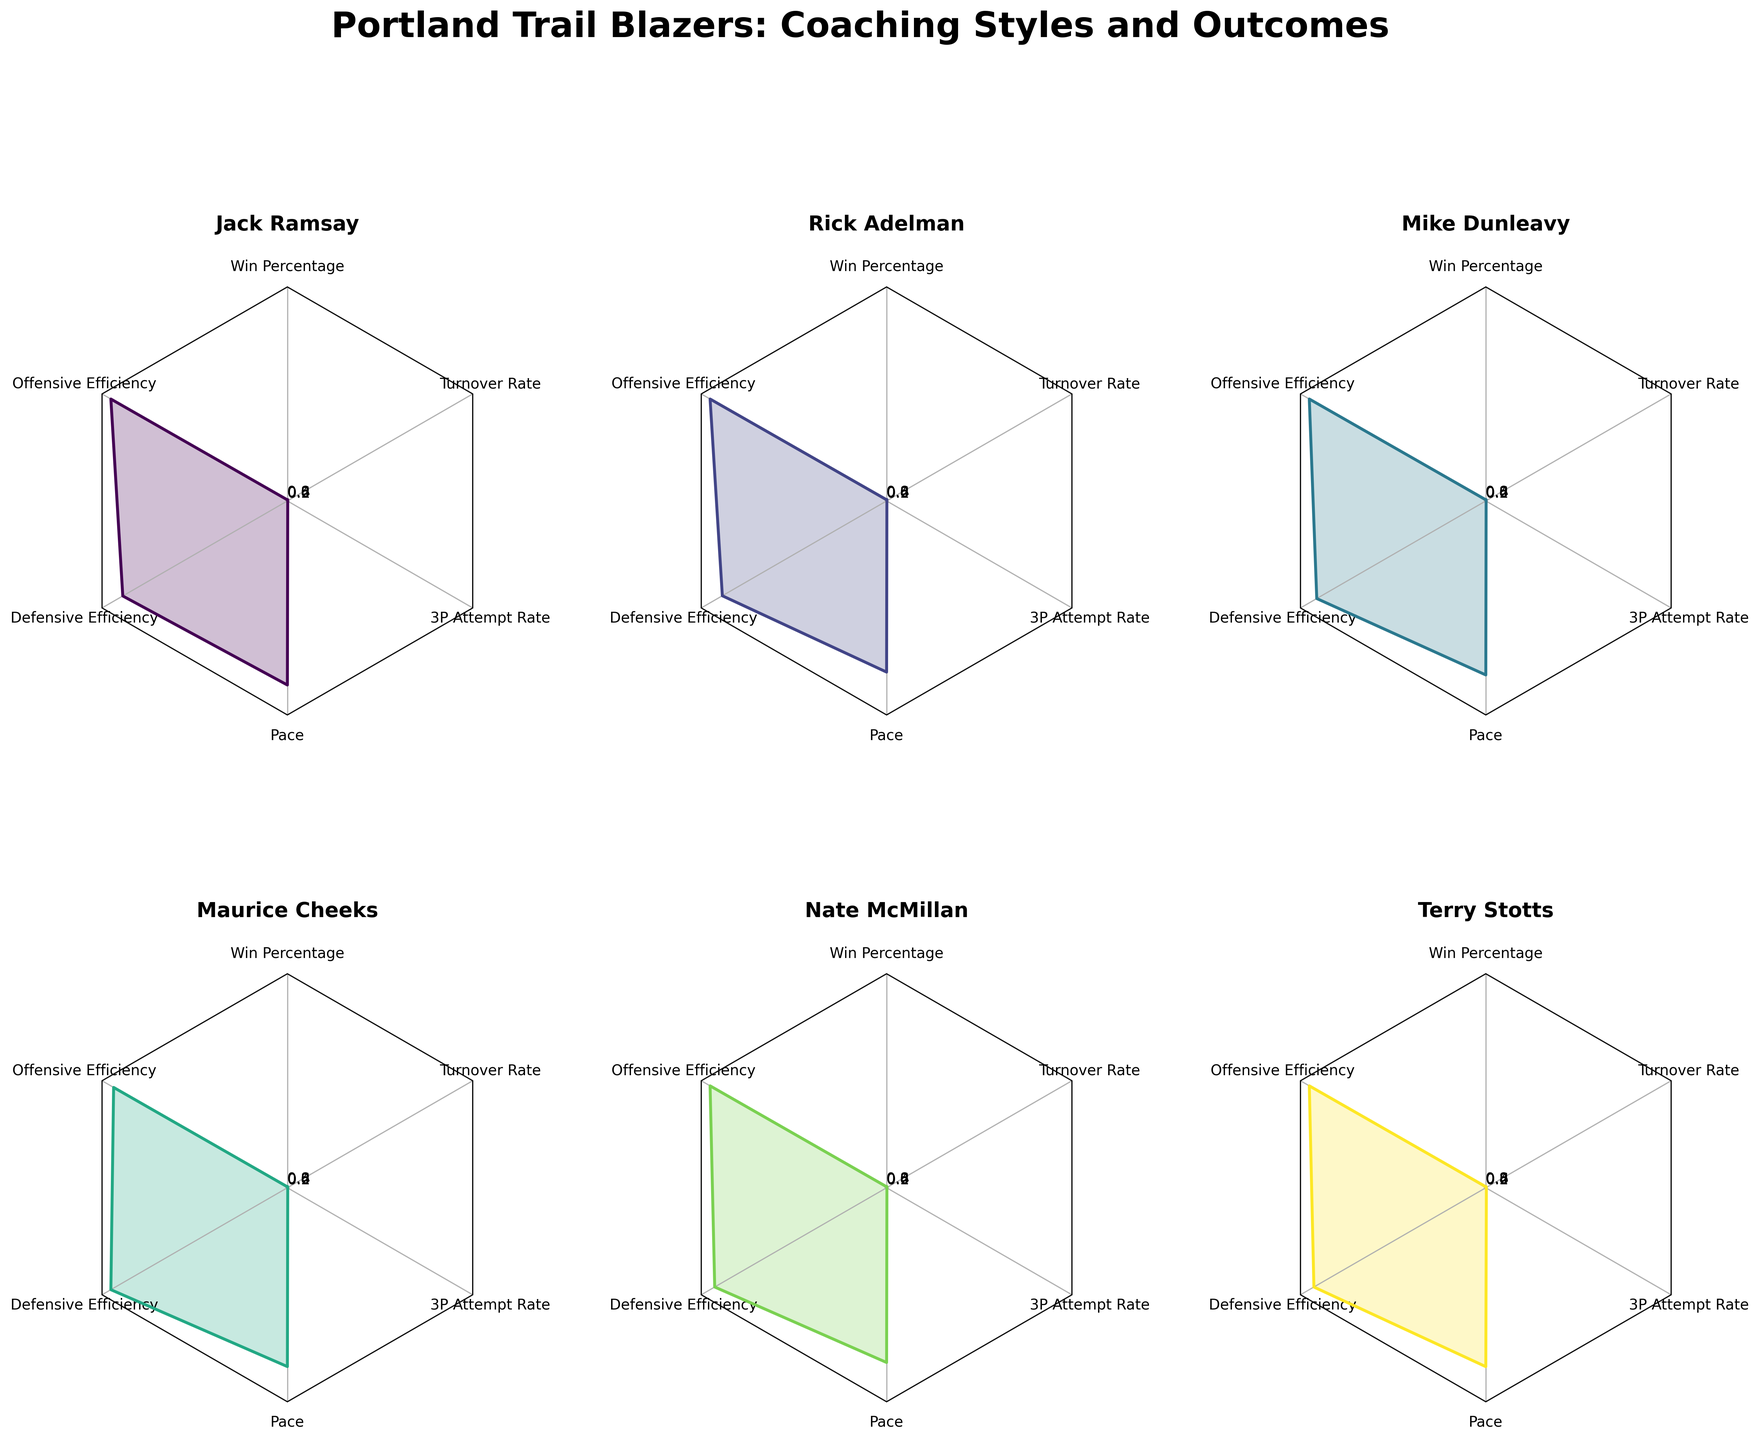What is the title of the figure? The title is located at the top of the figure in bold and large font size. It reads "Portland Trail Blazers: Coaching Styles and Outcomes", which indicates that the figure is comparing different coaching styles and their outcomes for the Portland Trail Blazers.
Answer: Portland Trail Blazers: Coaching Styles and Outcomes Which coach has the highest win percentage? By looking at the radar chart for each coach, you can identify that Rick Adelman has the largest value on the 'Win Percentage' axis.
Answer: Rick Adelman Who had the largest 3P Attempt Rate among the coaches? By comparing the '3P Attempt Rate' on each radar chart subplot, you'll notice that Terry Stotts has the largest value.
Answer: Terry Stotts How does the defensive efficiency of Jack Ramsay compare to Maurice Cheeks? By examining the 'Defensive Efficiency' axis on the radar charts for Jack Ramsay and Maurice Cheeks, you can see that Jack Ramsay has a larger value compared to Maurice Cheeks.
Answer: Jack Ramsay > Maurice Cheeks Which coach’s team played at the fastest pace? By examining the 'Pace' axis on each radar chart, Terry Stotts's chart shows the highest value on the 'Pace' axis.
Answer: Terry Stotts Calculate the average Offensive Efficiency for the defensive-focused coaches. Identify the defensive-focused coaches: Jack Ramsay, Maurice Cheeks, Nate McMillan. The offensive efficiencies are 105.2, 101.1, and 103.0, respectively. Average = (105.2 + 101.1 + 103.0) / 3
Answer: 103.1 Who had the highest turnover rate and what was that value? By comparing the 'Turnover Rate' on each radar chart, Maurice Cheeks has the highest value. The rate is displayed on his radar chart.
Answer: Maurice Cheeks, 0.145 Compare Nate McMillan’s win percentage with Terry Stotts. By examining the 'Win Percentage' axis on their radar charts, Nate McMillan’s value is lower than Terry Stotts’s value.
Answer: Nate McMillan < Terry Stotts Which coach has a balanced focus? The radar chart titles include the focus type. By looking at these titles, you see that Mike Dunleavy is the one listed with a 'Balanced' focus.
Answer: Mike Dunleavy Among offensive-focused coaches, who had better defensive efficiency, and by how much? The offensive-focused coaches are Rick Adelman and Terry Stotts. Compare the 'Defensive Efficiency' axis on their radar charts, Rick Adelman’s chart shows a 104.5 while Terry Stotts’s shows 108.3. The difference is 108.3 - 104.5 = 3.8
Answer: Rick Adelman, by 3.8 